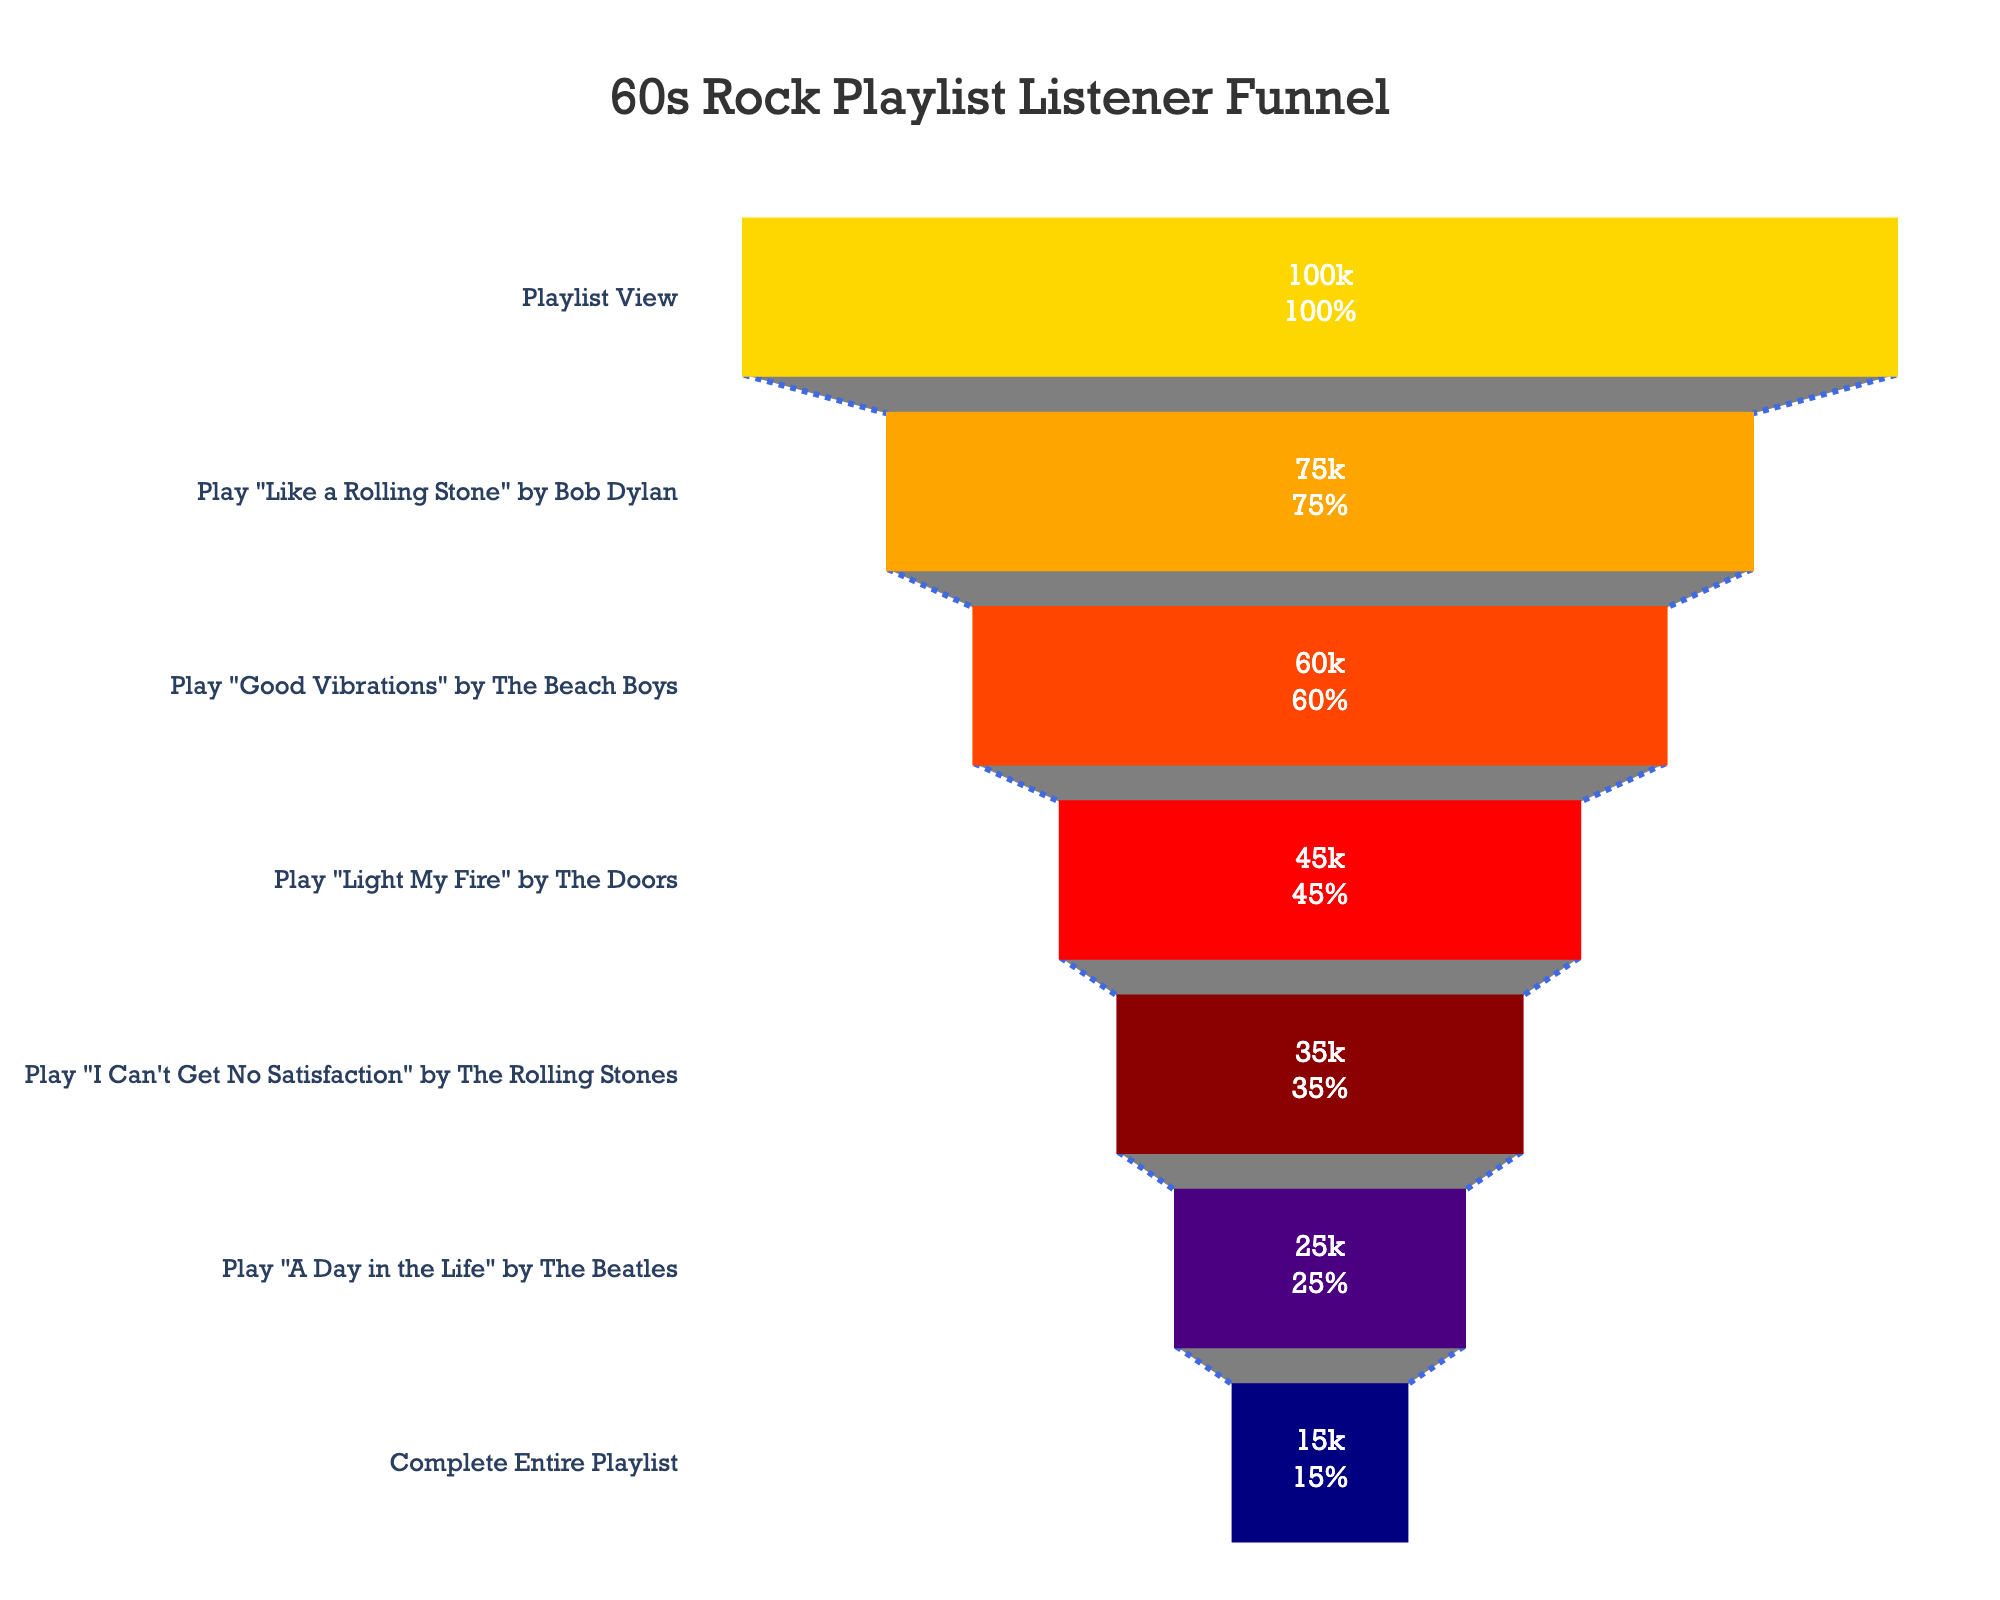What's the title of the figure? The title is displayed prominently at the top center of the funnel chart. It reads "60s Rock Playlist Listener Funnel".
Answer: 60s Rock Playlist Listener Funnel How many stages are there in the funnel? The funnel chart visually represents each stage linearly, with seven distinct stages from "Playlist View" to "Complete Entire Playlist".
Answer: Seven Which song has the highest drop-off in listener numbers? To identify the highest drop-off, observe the difference in listeners between consecutive stages. "Play 'Light My Fire'" to "Play 'I Can't Get No Satisfaction'" drops from 45000 to 35000, the largest drop of 10000 listeners.
Answer: Play "Light My Fire" by The Doors What's the percentage of listeners who played "Good Vibrations" after viewing the playlist? "Good Vibrations" has 60000 listeners, and the initial number of listeners at "Playlist View" is 100000. The percentage is (60000/100000) * 100.
Answer: 60% What percentage of listeners completed the entire playlist? The final stage "Complete Entire Playlist" has 15000 listeners out of 100000 initial listeners. (15000/100000) * 100 = 15%.
Answer: 15% Compare the listener retention between playing "Like a Rolling Stone" and "Good Vibrations". For "Like a Rolling Stone", retention is 75000/100000 = 75%. For "Good Vibrations", retention is 60000/100000 = 60%. Comparing these percentages shows "Like a Rolling Stone" has a higher retention rate.
Answer: "Like a Rolling Stone" Which stage retains the fewest listeners? The final stage, "Complete Entire Playlist," has the fewest listeners with 15000.
Answer: Complete Entire Playlist Calculate the overall attrition rate from "Playlist View" to "Complete Entire Playlist". Attrition rate is defined as 1 - (final stage listeners/initial stage listeners). Here, it is 1 - (15000/100000) which equals 0.85 or 85%.
Answer: 85% What's the retention ratio between "Play 'A Day in the Life'" and "Complete Entire Playlist"? Divide the number of listeners completing the playlist (15000) by listeners at the start of "A Day in the Life" (25000). 15000/25000 equals 0.6 or 60%.
Answer: 60% How does the retention from "Play 'Good Vibrations'" to "Play 'Light My Fire'" compare to the retention from "Play 'I Can't Get No Satisfaction'" to "A Day in the Life"? "Good Vibrations" to "Light My Fire" has a retention rate of 45000/60000 = 75%. "I Can't Get No Satisfaction" to "A Day in the Life" has a rate of 25000/35000 ≈ 71.4%. Thus, the retention is slightly better from "Good Vibrations" to "Light My Fire".
Answer: Better from "Good Vibrations" to "Light My Fire" 